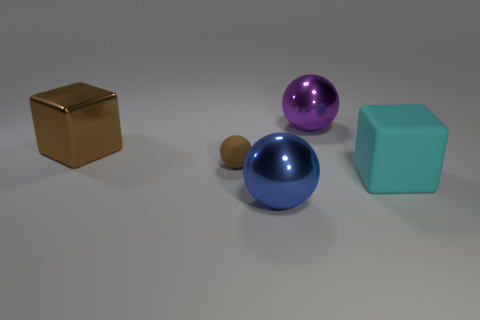What is the shape of the large cyan thing? The large cyan object in the image is a geometric shape known as a cube, which has six square faces of equal size, twelve straight edges, and eight vertices. The uniformity of its dimensions and angles gives the cube its distinctive appearance. 